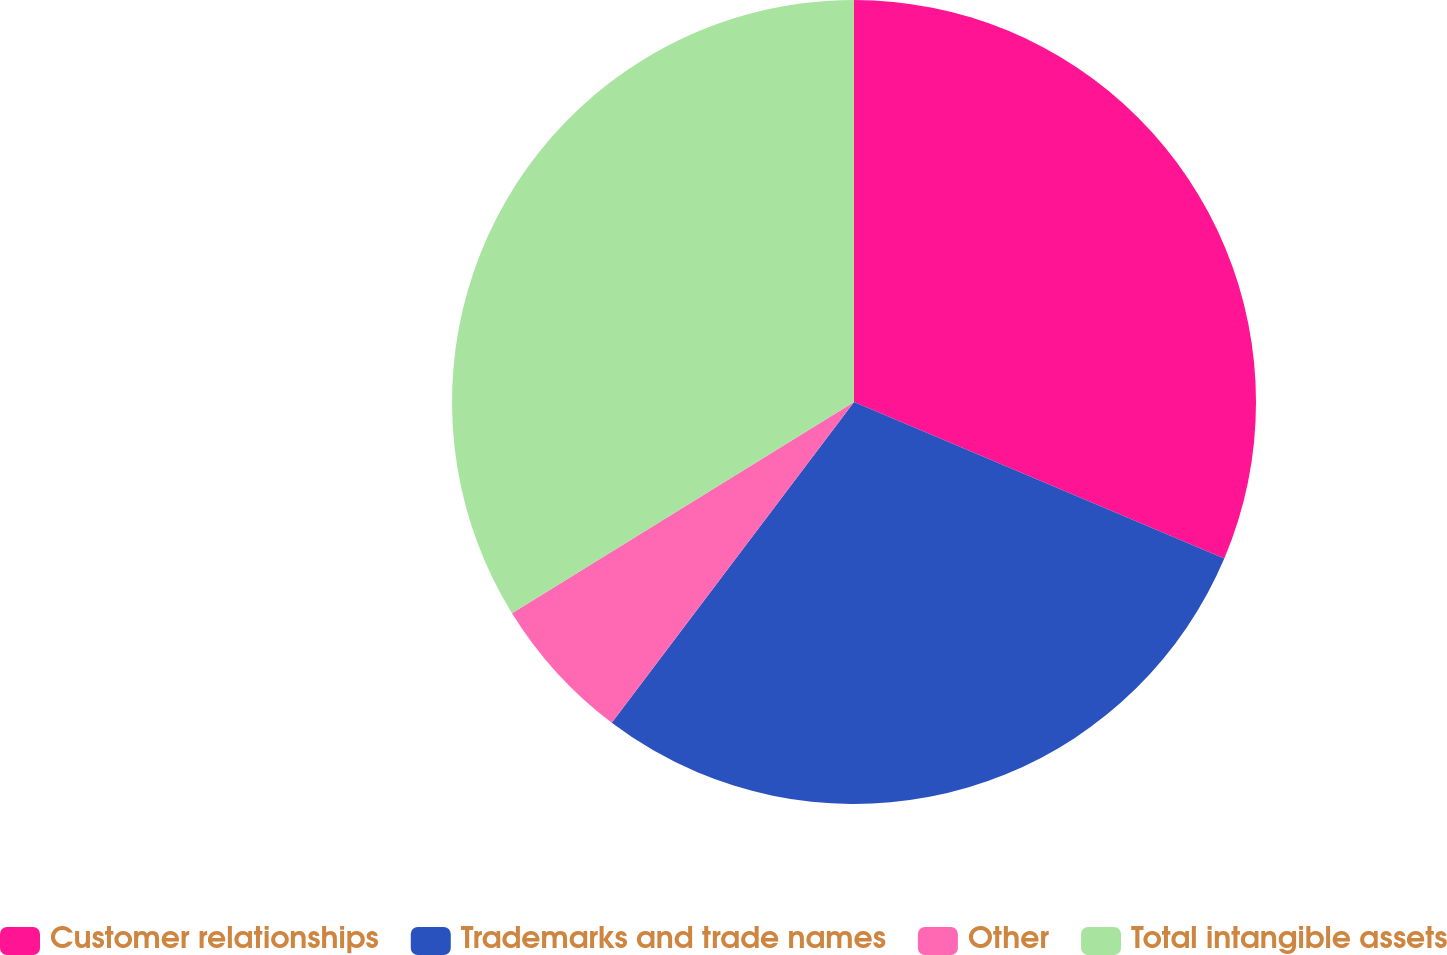Convert chart. <chart><loc_0><loc_0><loc_500><loc_500><pie_chart><fcel>Customer relationships<fcel>Trademarks and trade names<fcel>Other<fcel>Total intangible assets<nl><fcel>31.37%<fcel>28.93%<fcel>5.9%<fcel>33.81%<nl></chart> 